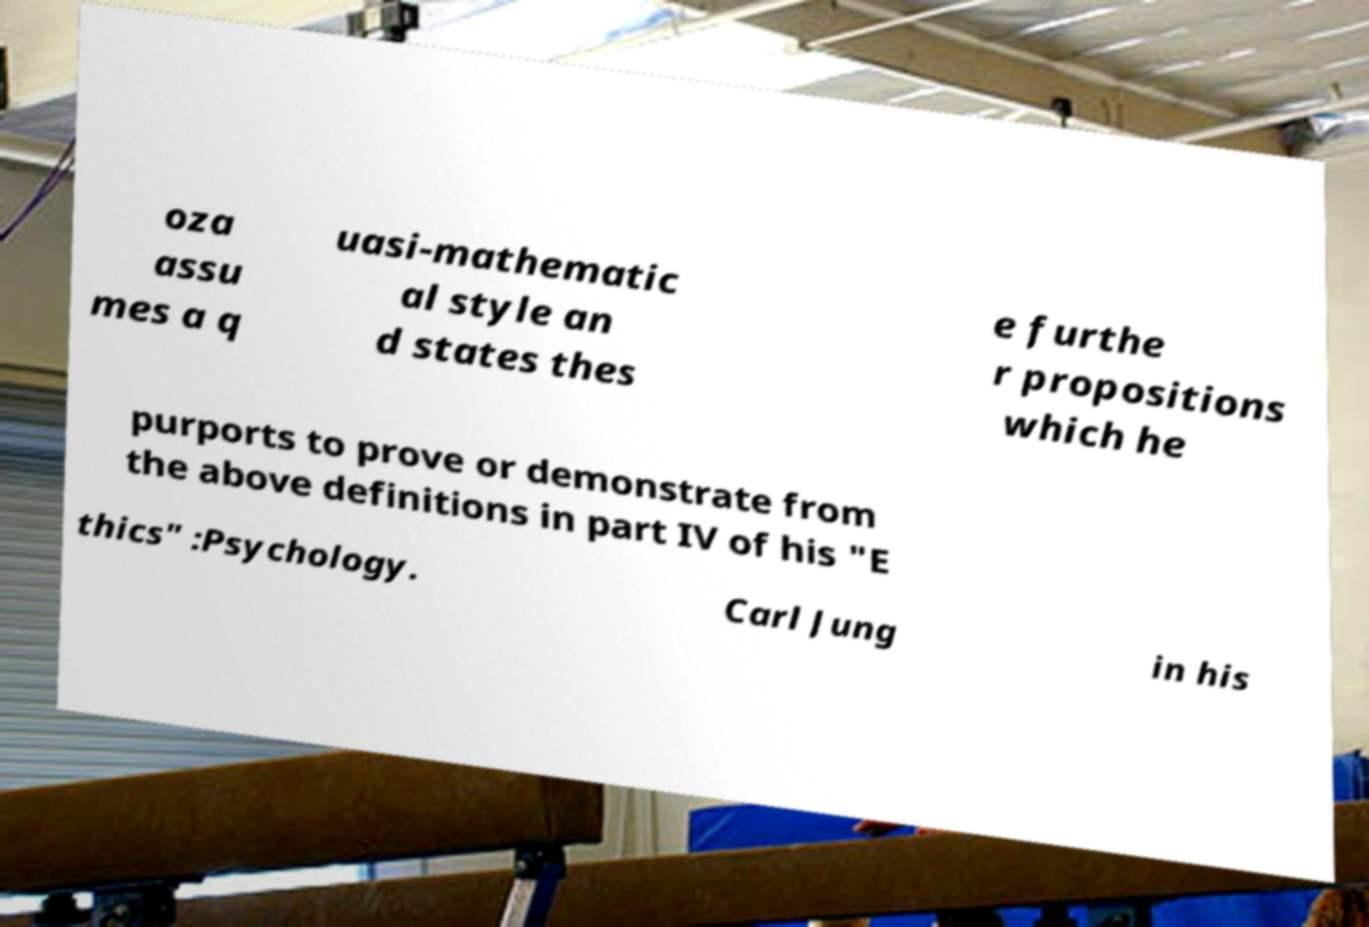Can you read and provide the text displayed in the image?This photo seems to have some interesting text. Can you extract and type it out for me? oza assu mes a q uasi-mathematic al style an d states thes e furthe r propositions which he purports to prove or demonstrate from the above definitions in part IV of his "E thics" :Psychology. Carl Jung in his 